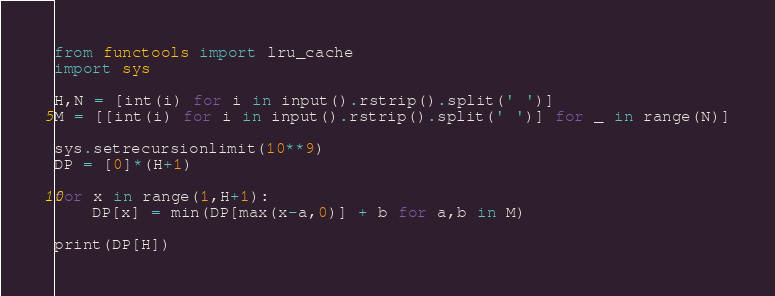Convert code to text. <code><loc_0><loc_0><loc_500><loc_500><_Python_>from functools import lru_cache
import sys

H,N = [int(i) for i in input().rstrip().split(' ')]
M = [[int(i) for i in input().rstrip().split(' ')] for _ in range(N)]

sys.setrecursionlimit(10**9)
DP = [0]*(H+1)

for x in range(1,H+1):
    DP[x] = min(DP[max(x-a,0)] + b for a,b in M)

print(DP[H])</code> 